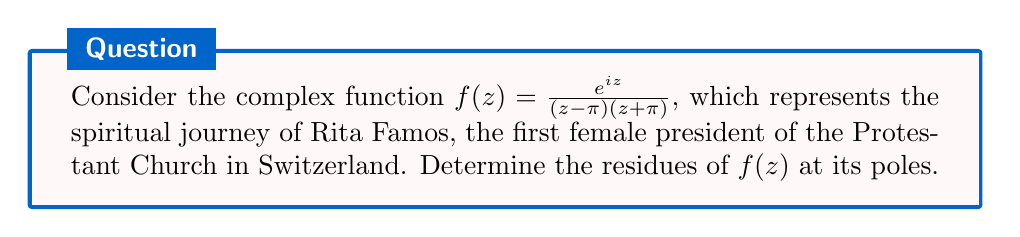What is the answer to this math problem? Let's approach this step-by-step:

1) First, we identify the poles of $f(z)$. The poles are at $z = \pi$ and $z = -\pi$.

2) For $z = \pi$:
   The residue at $z = \pi$ is given by:
   $$\text{Res}(f, \pi) = \lim_{z \to \pi} (z-\pi)f(z) = \lim_{z \to \pi} \frac{e^{iz}}{z+\pi}$$
   
   Using L'Hôpital's rule:
   $$\text{Res}(f, \pi) = \lim_{z \to \pi} \frac{ie^{iz}}{1} = \frac{ie^{i\pi}}{2\pi} = -\frac{i}{2\pi}$$

3) For $z = -\pi$:
   The residue at $z = -\pi$ is given by:
   $$\text{Res}(f, -\pi) = \lim_{z \to -\pi} (z+\pi)f(z) = \lim_{z \to -\pi} \frac{e^{iz}}{z-\pi}$$
   
   Using L'Hôpital's rule:
   $$\text{Res}(f, -\pi) = \lim_{z \to -\pi} \frac{ie^{iz}}{1} = \frac{ie^{-i\pi}}{-2\pi} = \frac{i}{2\pi}$$

These residues represent the spiritual influence at key moments in Rita Famos's journey to becoming the first female president of the Protestant Church in Switzerland.
Answer: $\text{Res}(f, \pi) = -\frac{i}{2\pi}$, $\text{Res}(f, -\pi) = \frac{i}{2\pi}$ 